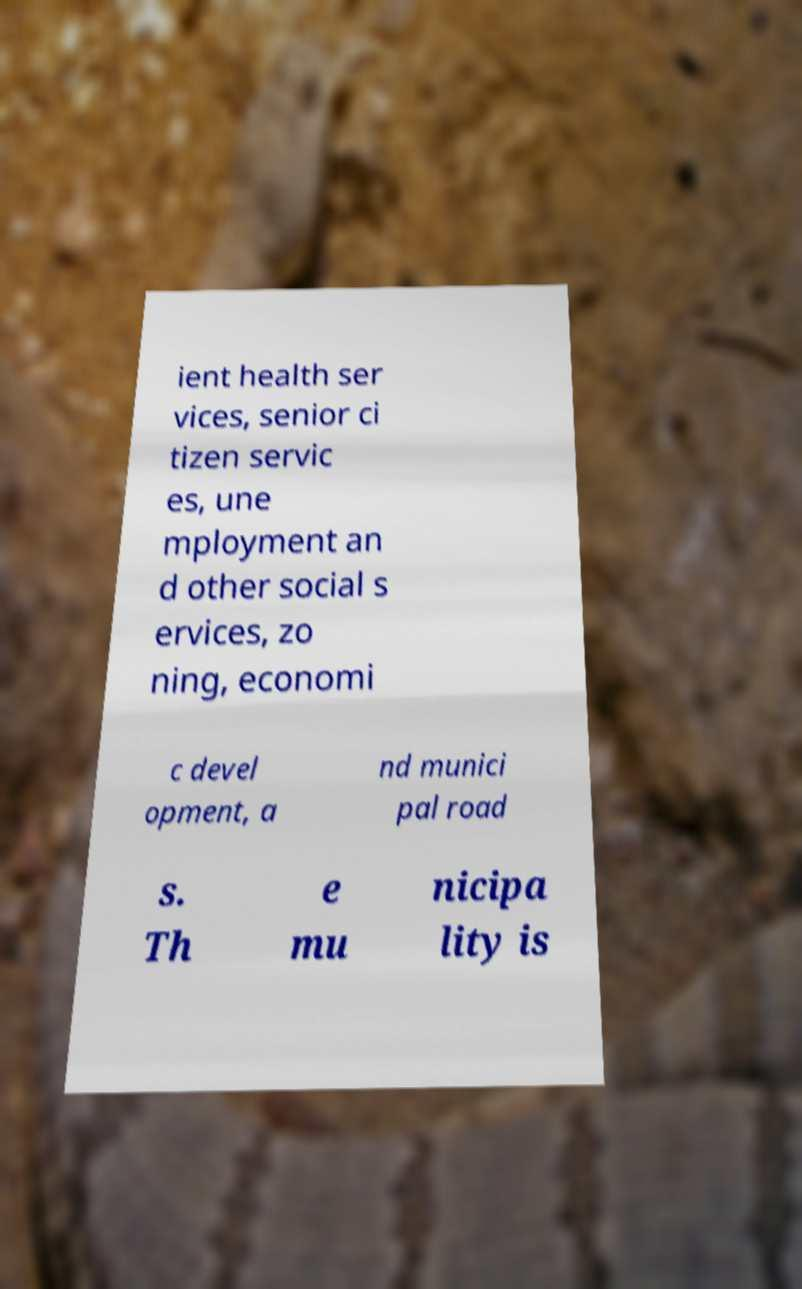Please identify and transcribe the text found in this image. ient health ser vices, senior ci tizen servic es, une mployment an d other social s ervices, zo ning, economi c devel opment, a nd munici pal road s. Th e mu nicipa lity is 